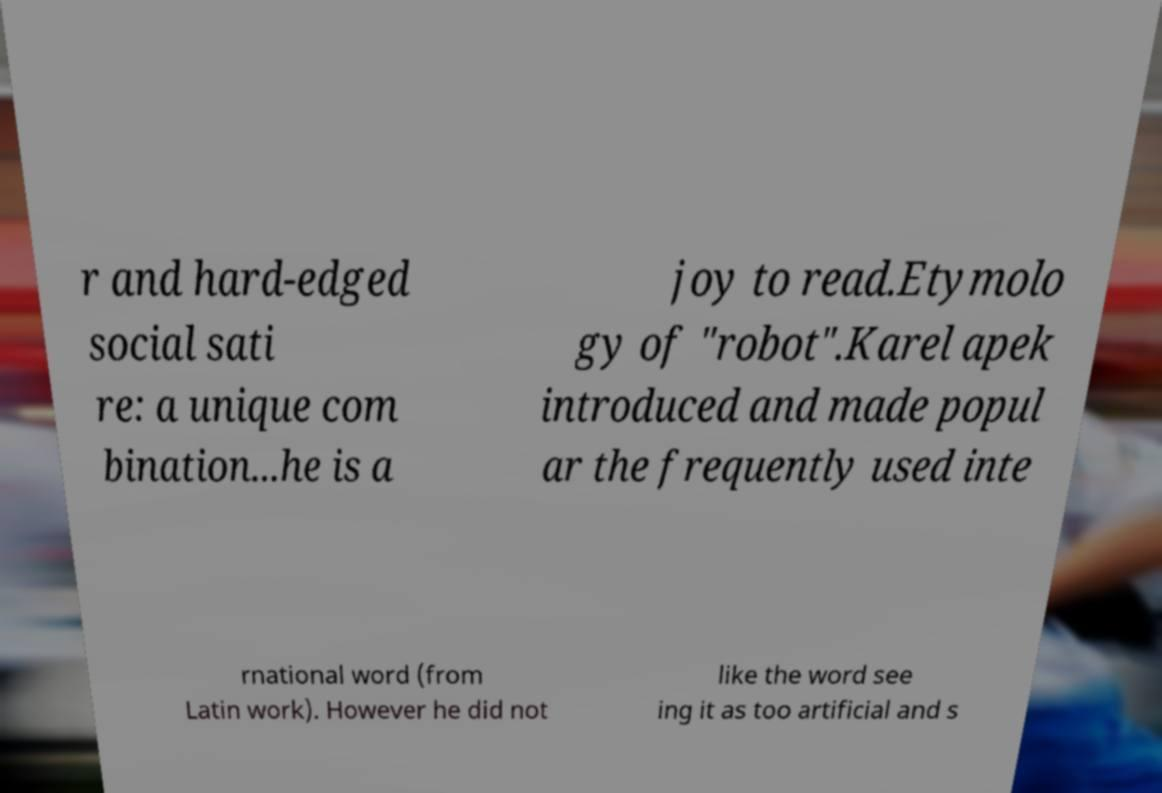For documentation purposes, I need the text within this image transcribed. Could you provide that? r and hard-edged social sati re: a unique com bination...he is a joy to read.Etymolo gy of "robot".Karel apek introduced and made popul ar the frequently used inte rnational word (from Latin work). However he did not like the word see ing it as too artificial and s 